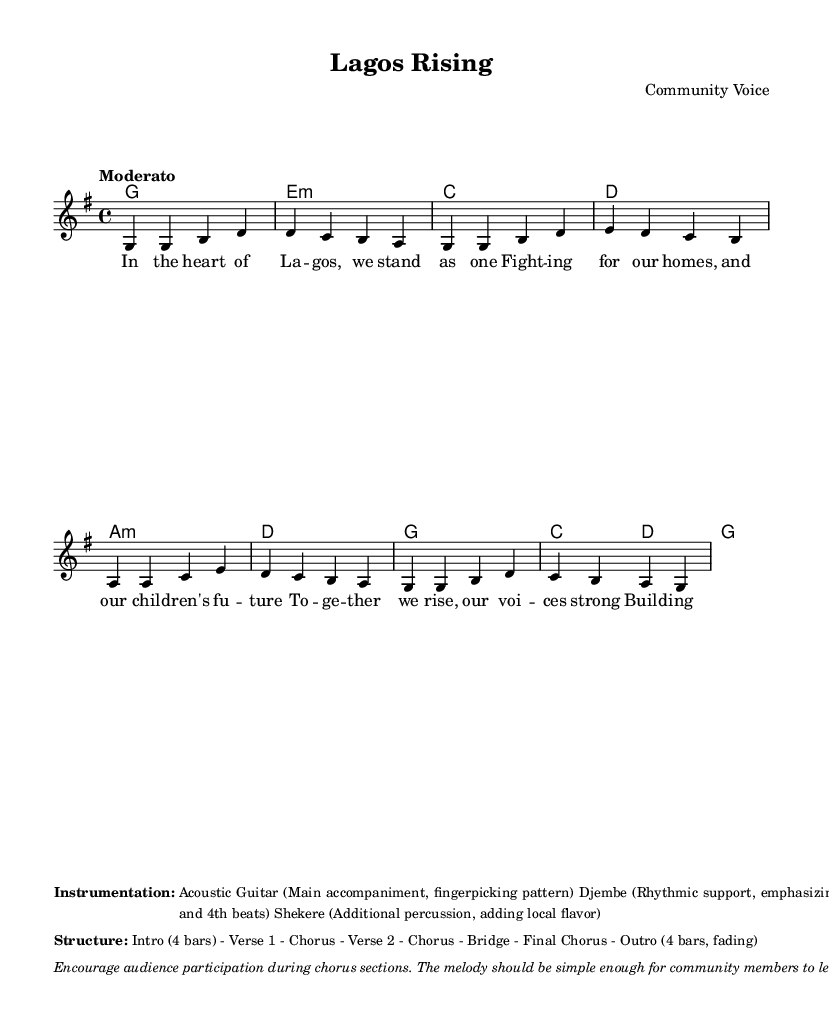What is the key signature of this music? The key signature is G major, which has one sharp (F#). It can be identified by looking at the key signature section at the beginning of the score.
Answer: G major What is the time signature of the piece? The time signature is 4/4, which indicates there are four beats in each measure and the quarter note gets one beat. This is shown in the time signature indication at the start of the score.
Answer: 4/4 What is the tempo marking for the song? The tempo marking is "Moderato," which indicates a moderate pace of the music. This marking is indicated at the beginning of the score, typically under the title or at the start of the music.
Answer: Moderato How many bars are in the intro section? The intro section consists of 4 bars, as specified in the structure section of the markup. This information shows that it precedes the first verse of the song.
Answer: 4 bars What instruments are used in this piece? The instruments listed are Acoustic Guitar, Djembe, and Shekere. This information can be found in the 'Instrumentation' section of the markup, which details the instruments involved in the performance.
Answer: Acoustic Guitar, Djembe, Shekere What is the structure of the song? The structure includes Intro (4 bars) - Verse 1 - Chorus - Verse 2 - Chorus - Bridge - Final Chorus - Outro (4 bars, fading). This is outlined in the Structure section of the markup.
Answer: Intro (4 bars) - Verse 1 - Chorus - Verse 2 - Chorus - Bridge - Final Chorus - Outro (4 bars, fading) What theme does the song represent? The theme of the song is community resilience and grassroots activism, as suggested by the lyrics and the general context of the song. This information reflects the overall message conveyed through the lyrics and title.
Answer: Community resilience and grassroots activism 